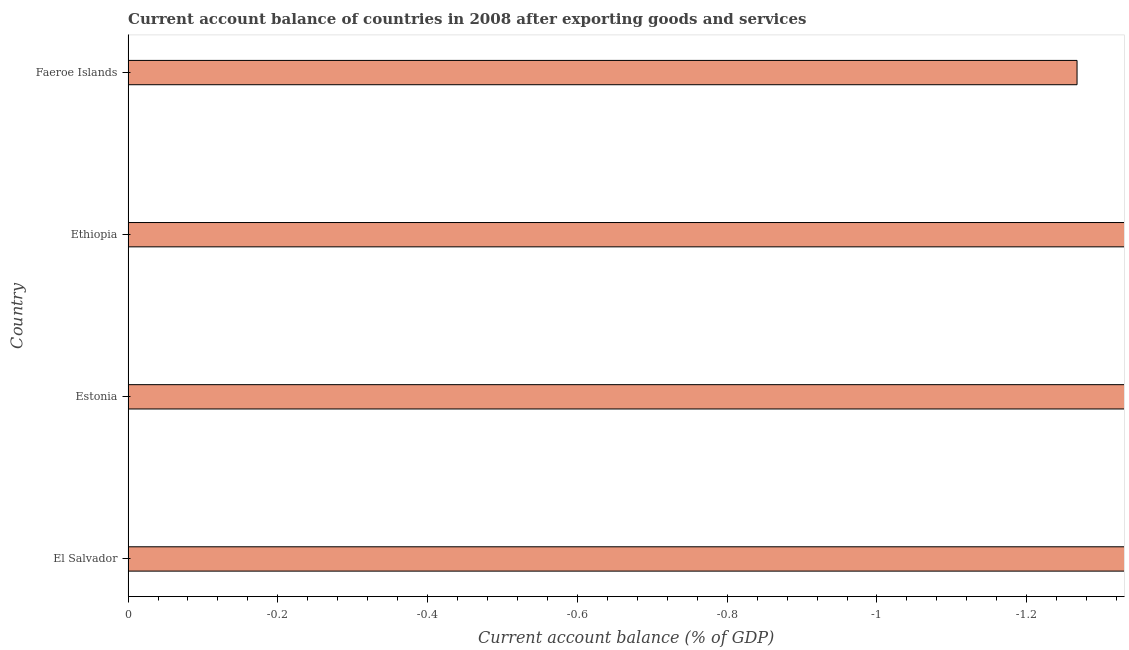What is the title of the graph?
Provide a succinct answer. Current account balance of countries in 2008 after exporting goods and services. What is the label or title of the X-axis?
Provide a short and direct response. Current account balance (% of GDP). What is the current account balance in Estonia?
Offer a terse response. 0. Across all countries, what is the minimum current account balance?
Offer a terse response. 0. What is the sum of the current account balance?
Give a very brief answer. 0. In how many countries, is the current account balance greater than -0.76 %?
Make the answer very short. 0. In how many countries, is the current account balance greater than the average current account balance taken over all countries?
Keep it short and to the point. 0. Are all the bars in the graph horizontal?
Offer a very short reply. Yes. What is the difference between two consecutive major ticks on the X-axis?
Make the answer very short. 0.2. Are the values on the major ticks of X-axis written in scientific E-notation?
Your response must be concise. No. What is the Current account balance (% of GDP) in El Salvador?
Your response must be concise. 0. What is the Current account balance (% of GDP) in Ethiopia?
Offer a terse response. 0. 